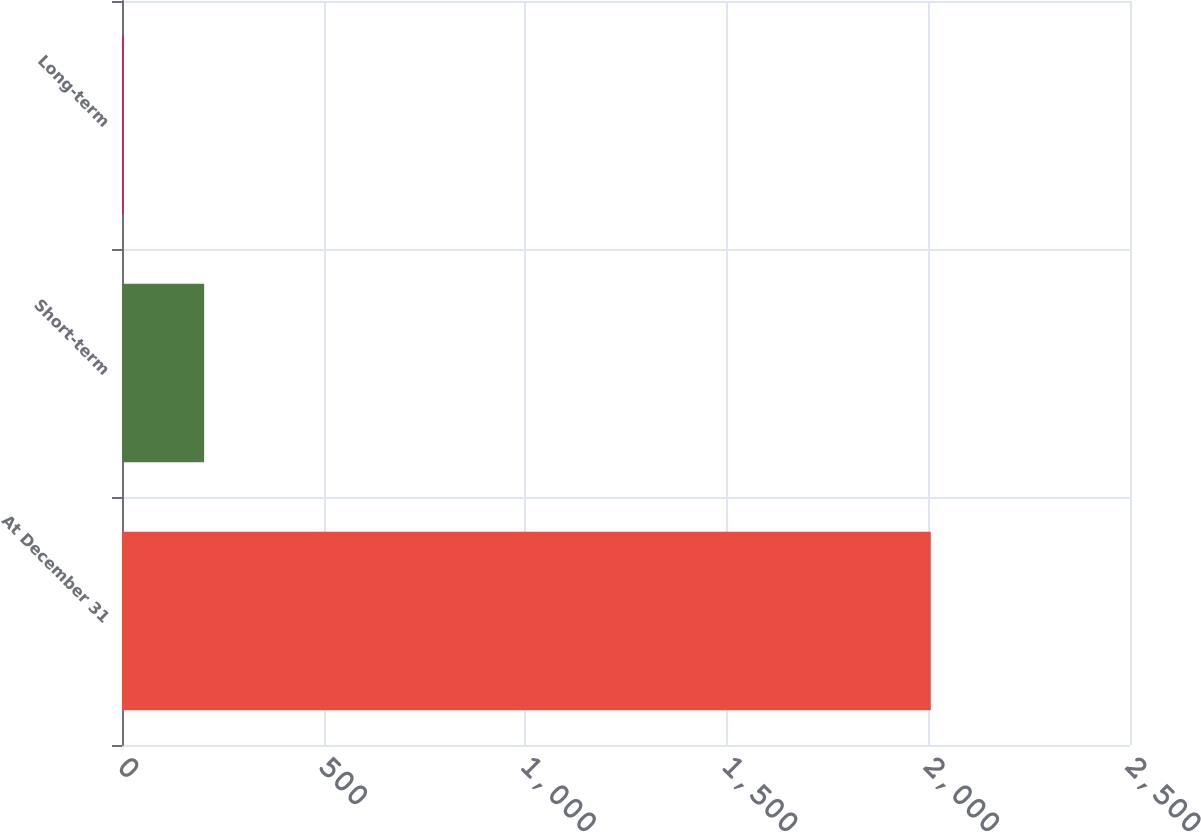Convert chart. <chart><loc_0><loc_0><loc_500><loc_500><bar_chart><fcel>At December 31<fcel>Short-term<fcel>Long-term<nl><fcel>2006<fcel>203.74<fcel>3.49<nl></chart> 